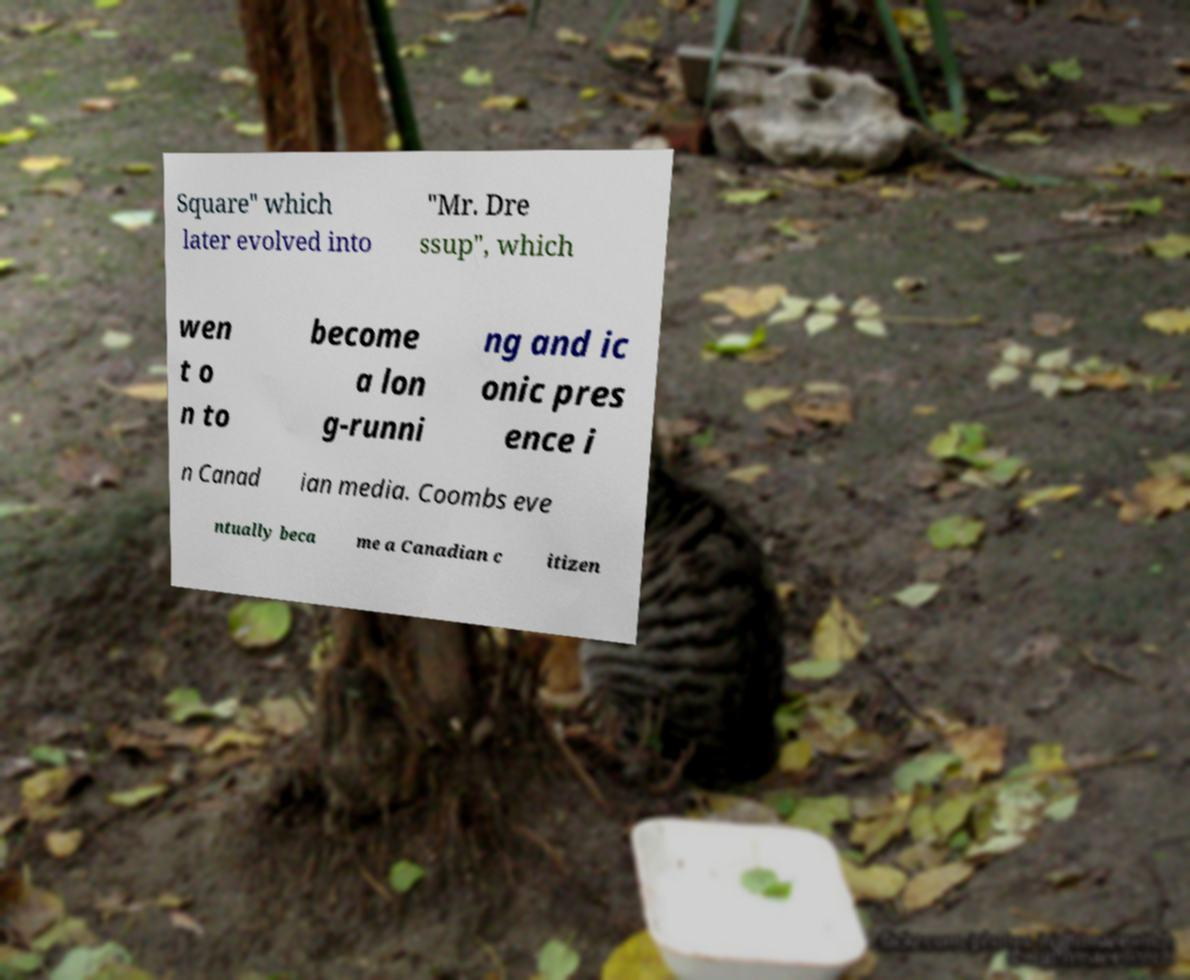Could you extract and type out the text from this image? Square" which later evolved into "Mr. Dre ssup", which wen t o n to become a lon g-runni ng and ic onic pres ence i n Canad ian media. Coombs eve ntually beca me a Canadian c itizen 